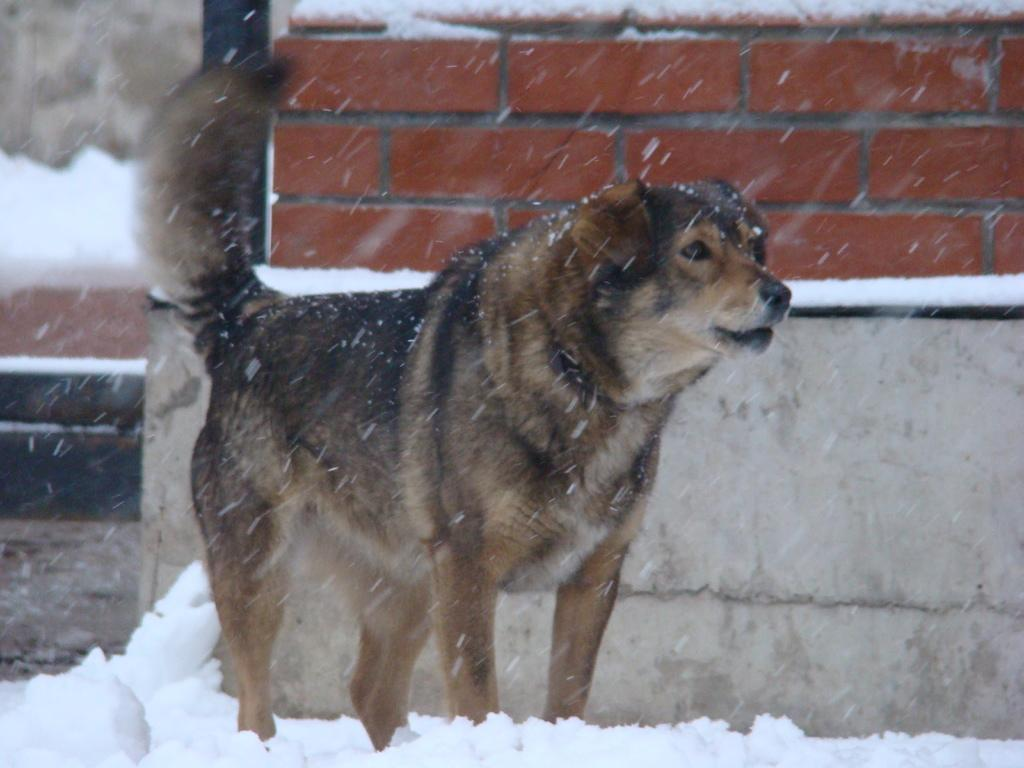What is the main subject in the foreground of the image? There is a dog in the foreground of the image. What is the dog standing on? The dog is standing on snow. What can be seen in the background of the image? There is a wall in the background of the image. How many fish can be seen swimming in the snow in the image? There are no fish present in the image, and fish cannot swim in snow. 